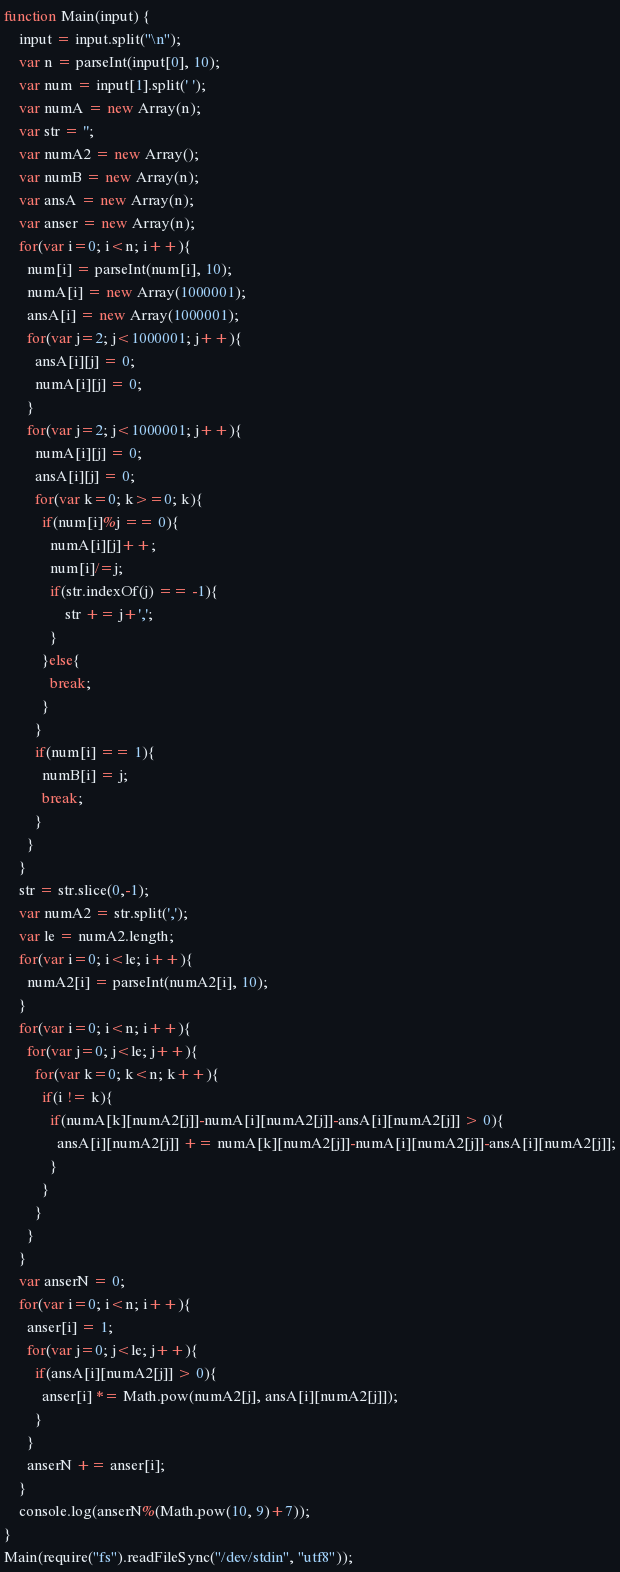<code> <loc_0><loc_0><loc_500><loc_500><_JavaScript_>function Main(input) {
    input = input.split("\n");
    var n = parseInt(input[0], 10);
    var num = input[1].split(' ');
    var numA = new Array(n);
    var str = '';
    var numA2 = new Array();
    var numB = new Array(n);
    var ansA = new Array(n);
    var anser = new Array(n);
    for(var i=0; i<n; i++){
      num[i] = parseInt(num[i], 10);
      numA[i] = new Array(1000001);
      ansA[i] = new Array(1000001);
      for(var j=2; j<1000001; j++){
        ansA[i][j] = 0;
        numA[i][j] = 0;
      }
      for(var j=2; j<1000001; j++){
        numA[i][j] = 0;
        ansA[i][j] = 0;
        for(var k=0; k>=0; k){
          if(num[i]%j == 0){
            numA[i][j]++;
            num[i]/=j;
            if(str.indexOf(j) == -1){
	        	str += j+',';
            }
          }else{
            break;
          }
        }
        if(num[i] == 1){
          numB[i] = j;
          break;
        }
      }
    }
    str = str.slice(0,-1);
    var numA2 = str.split(',');
    var le = numA2.length;
    for(var i=0; i<le; i++){
      numA2[i] = parseInt(numA2[i], 10);
    }
    for(var i=0; i<n; i++){
      for(var j=0; j<le; j++){
        for(var k=0; k<n; k++){
          if(i != k){
            if(numA[k][numA2[j]]-numA[i][numA2[j]]-ansA[i][numA2[j]] > 0){
              ansA[i][numA2[j]] += numA[k][numA2[j]]-numA[i][numA2[j]]-ansA[i][numA2[j]];
            }
          }
        }
      }
    }
    var anserN = 0;
    for(var i=0; i<n; i++){
      anser[i] = 1;
      for(var j=0; j<le; j++){
        if(ansA[i][numA2[j]] > 0){
          anser[i] *= Math.pow(numA2[j], ansA[i][numA2[j]]);
        }
      }
      anserN += anser[i];
    }
    console.log(anserN%(Math.pow(10, 9)+7));
}
Main(require("fs").readFileSync("/dev/stdin", "utf8"));</code> 